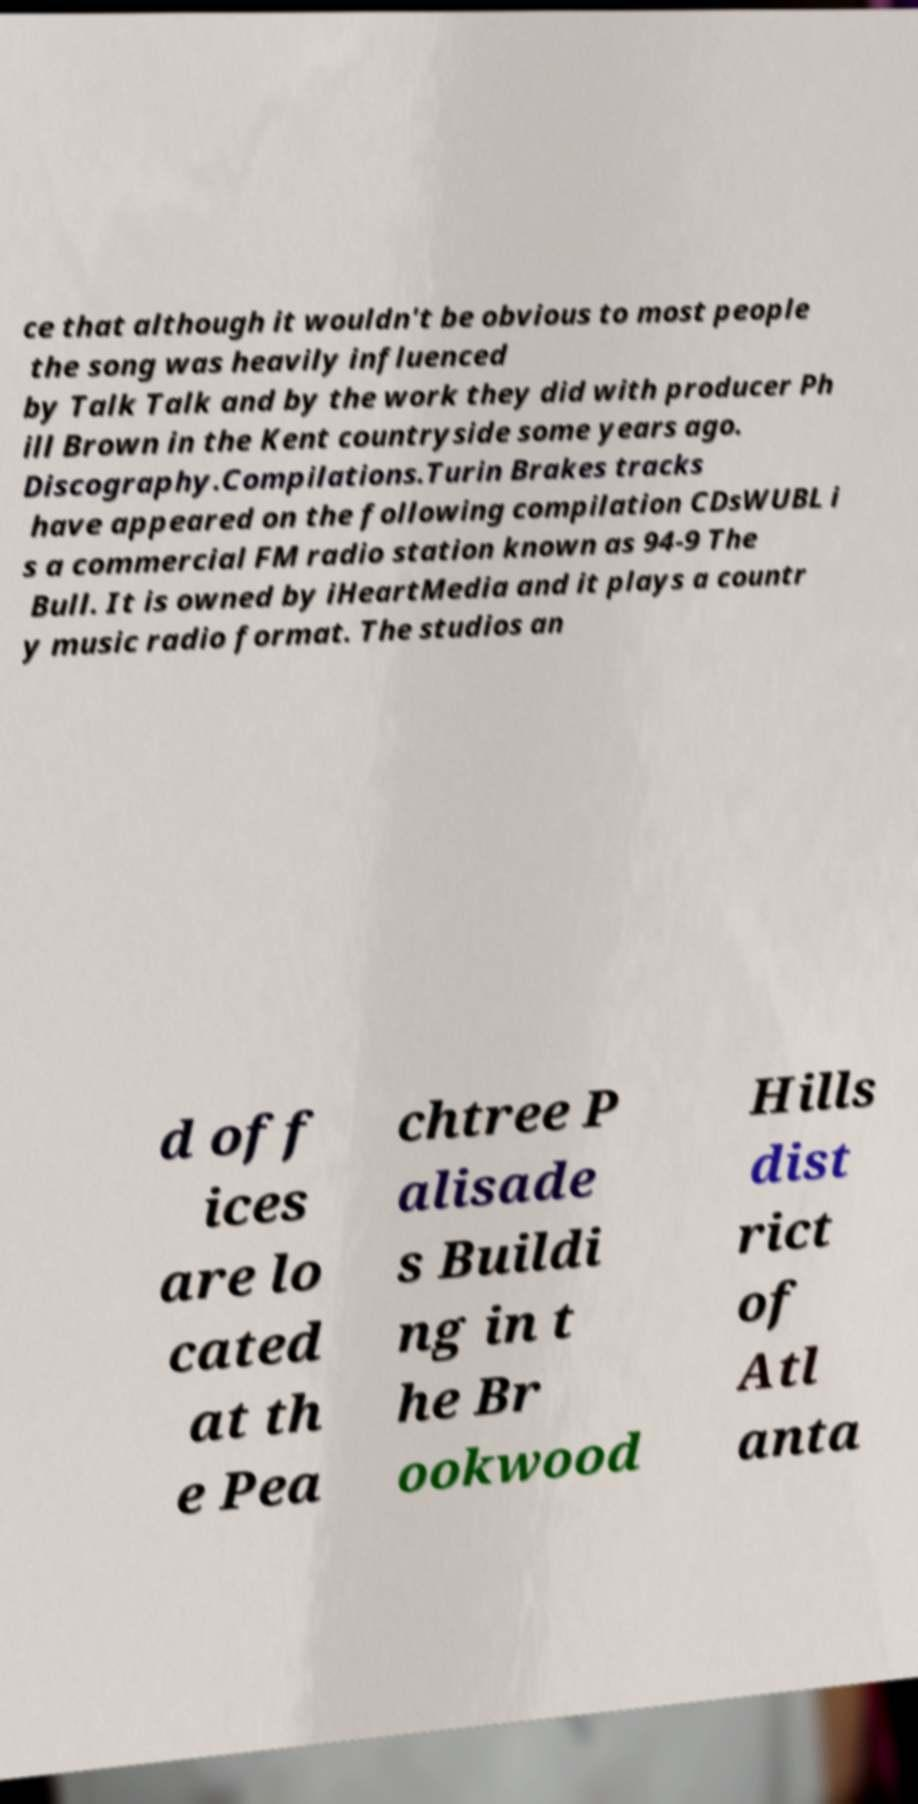For documentation purposes, I need the text within this image transcribed. Could you provide that? ce that although it wouldn't be obvious to most people the song was heavily influenced by Talk Talk and by the work they did with producer Ph ill Brown in the Kent countryside some years ago. Discography.Compilations.Turin Brakes tracks have appeared on the following compilation CDsWUBL i s a commercial FM radio station known as 94-9 The Bull. It is owned by iHeartMedia and it plays a countr y music radio format. The studios an d off ices are lo cated at th e Pea chtree P alisade s Buildi ng in t he Br ookwood Hills dist rict of Atl anta 